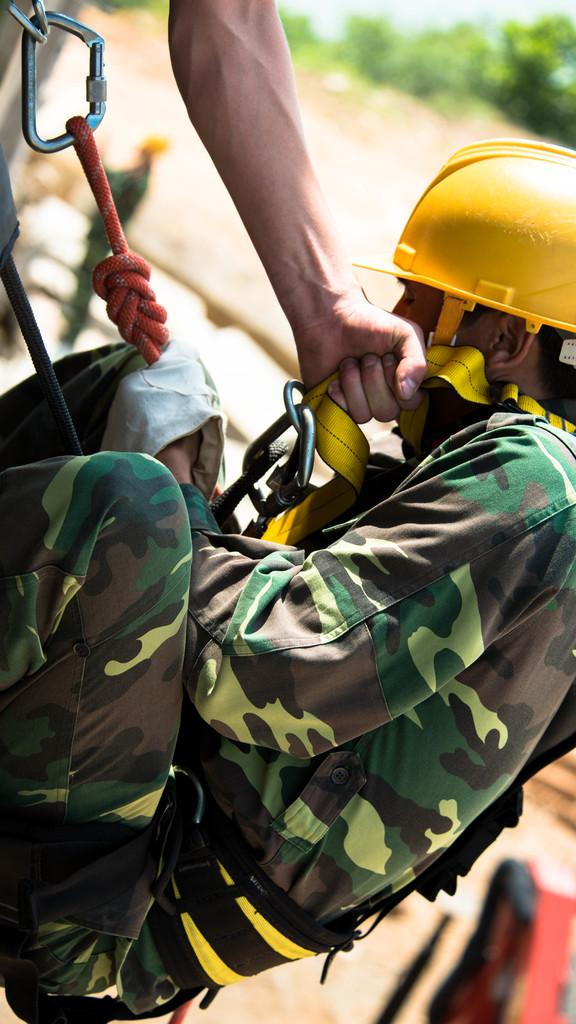What is the main subject of the image? There is a person in the image. What is the person doing in the image? The person is climbing. What can be seen in the background of the image? There are trees in the background of the image. What type of mitten is the person wearing while climbing in the image? There is no mitten visible in the image, and the person's hands are not shown. 